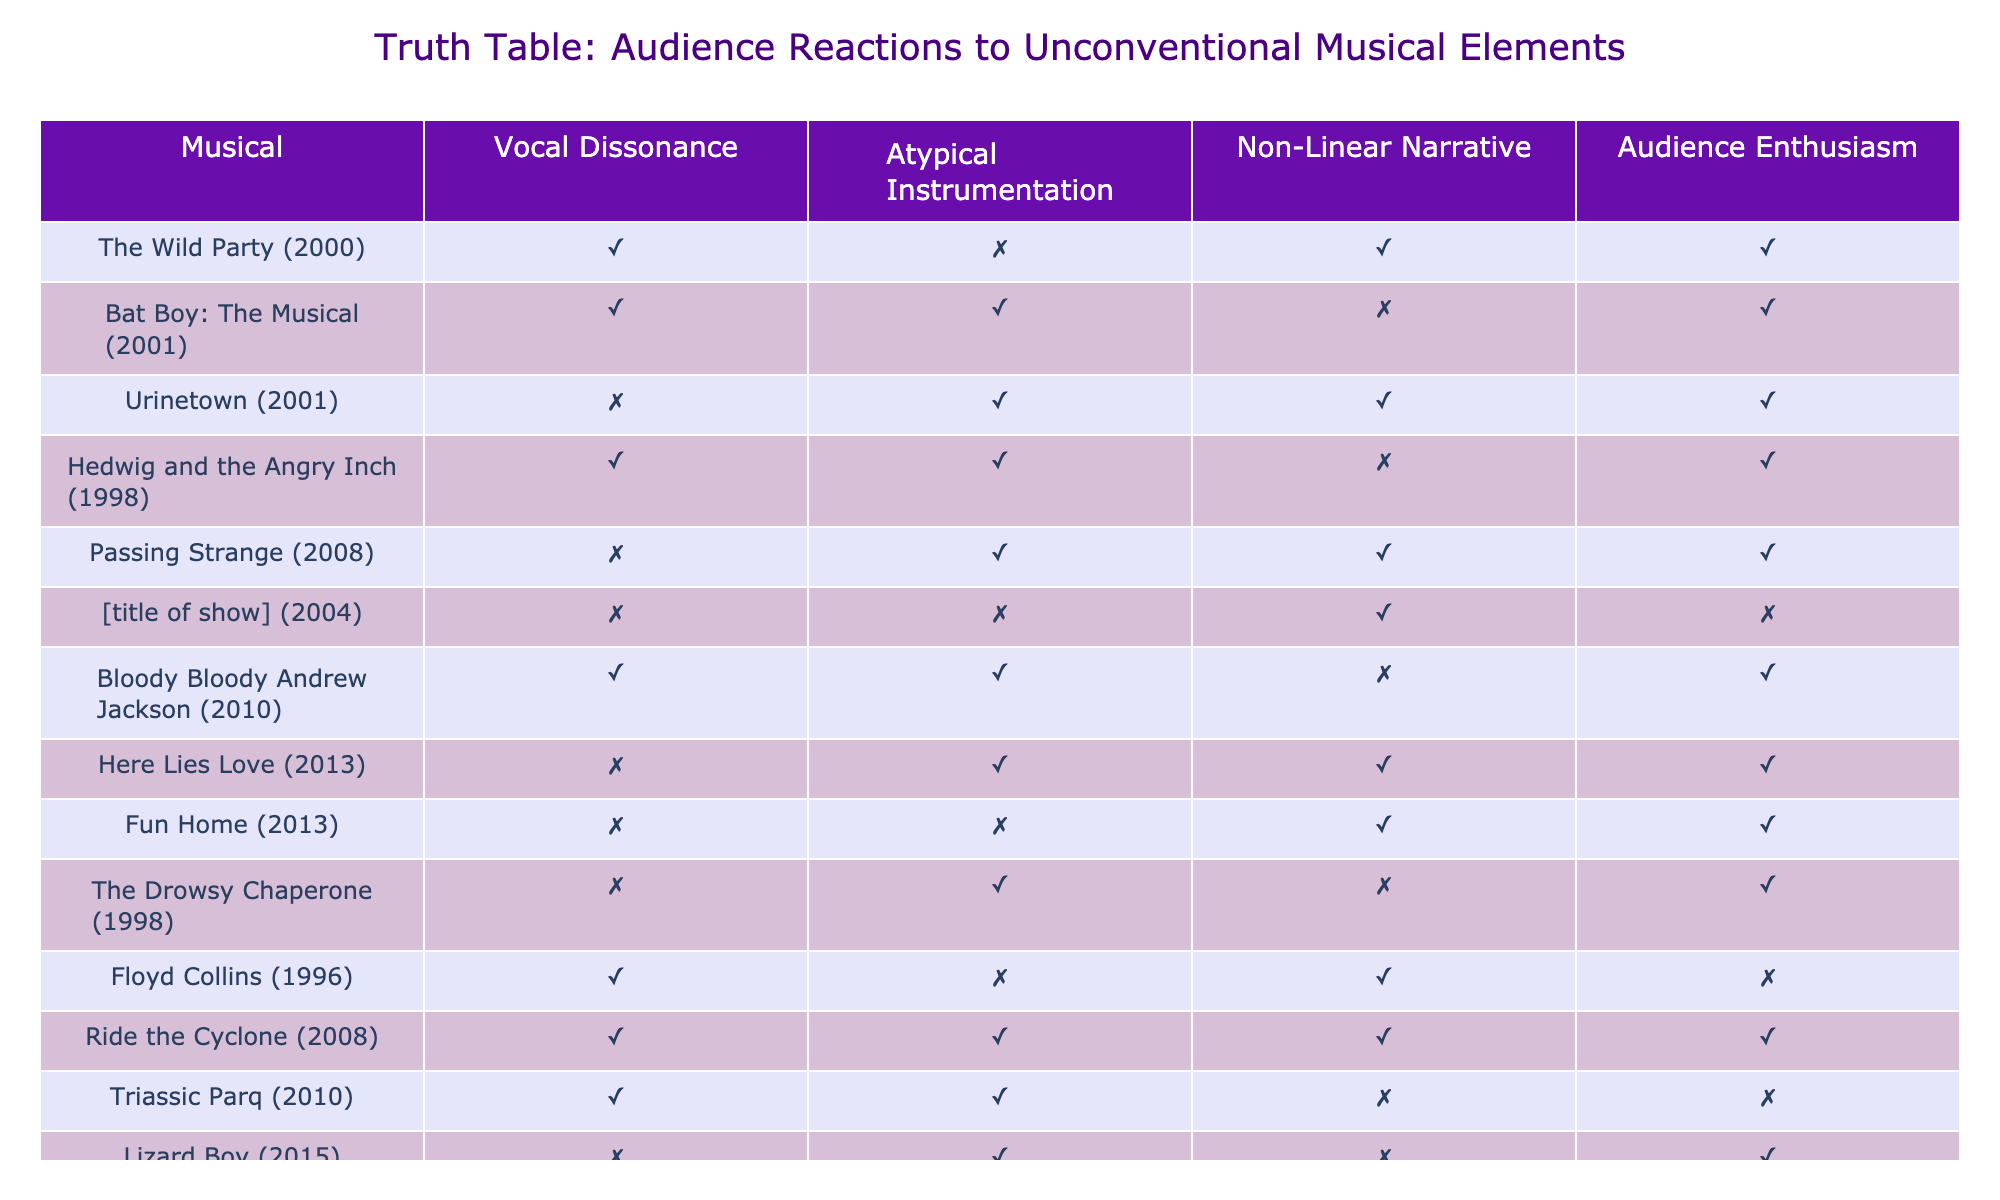What unconventional element does "Urinetown" exhibit? "Urinetown" shows Atypical Instrumentation and Non-Linear Narrative but does not feature Vocal Dissonance. We can determine this by checking the respective columns corresponding to "Urinetown" in the table.
Answer: Atypical Instrumentation and Non-Linear Narrative How many musicals feature both Vocal Dissonance and Atypical Instrumentation? By examining the table, we see that "Bat Boy: The Musical," "Hedwig and the Angry Inch," "Bloody Bloody Andrew Jackson," and "Ride the Cyclone" all have both Vocal Dissonance and Atypical Instrumentation, totaling four musicals.
Answer: 4 Does "Fun Home" have any unconventional elements? According to the table, "Fun Home" does not exhibit Vocal Dissonance or Atypical Instrumentation but does feature a Non-Linear Narrative. Thus, it has one unconventional element.
Answer: Yes What is the total number of musicals that showcase both Non-Linear Narrative and Audience Enthusiasm? When looking at the table, the musicals that meet these criteria are "The Wild Party," "Urinetown," "Hedwig and the Angry Inch," "Passing Strange," "Here Lies Love," and "Fun Home." This gives a total of six musicals.
Answer: 6 Which musical has Vocal Dissonance but lacks Audience Enthusiasm? By checking the table, "Floyd Collins" is the only musical that exhibits Vocal Dissonance (TRUE) while simultaneously lacking Audience Enthusiasm (FALSE).
Answer: "Floyd Collins" Are there any musicals without Atypical Instrumentation? Upon reviewing the table, we find that "The Wild Party," "Urinetown," "[title of show]," "Floyd Collins," and "Lizard Boy" do not feature Atypical Instrumentation. This confirms that there are several such musicals.
Answer: Yes How many musicals have a Non-Linear Narrative but do not show Audience Enthusiasm? The table indicates that "[title of show]" and "Triassic Parq" have a Non-Linear Narrative (TRUE) but lack Audience Enthusiasm (FALSE). This amounts to a total of two musicals.
Answer: 2 Which unconventional element is most frequently observed among the musicals listed? Analyzing the table, Vocal Dissonance appears in "The Wild Party," "Bat Boy: The Musical," "Hedwig and the Angry Inch," "Bloody Bloody Andrew Jackson," and "Ride the Cyclone," totaling five occurrences, making it the most frequent unconventional element.
Answer: Vocal Dissonance What proportion of musicals with Atypical Instrumentation also have Audience Enthusiasm? From the table, there are six musicals with Atypical Instrumentation that are "Bat Boy: The Musical," "Urinetown," "Hedwig and the Angry Inch," "Bloody Bloody Andrew Jackson," "Here Lies Love," and "Lizard Boy." Out of these, four also show Audience Enthusiasm. Therefore, the proportion is 4 out of 6, which simplifies to 2/3.
Answer: 2/3 